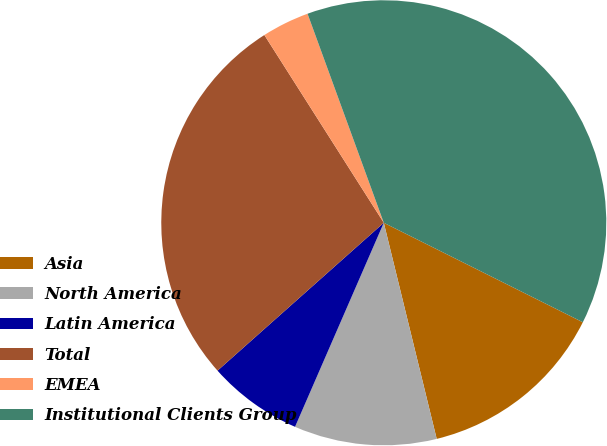Convert chart. <chart><loc_0><loc_0><loc_500><loc_500><pie_chart><fcel>Asia<fcel>North America<fcel>Latin America<fcel>Total<fcel>EMEA<fcel>Institutional Clients Group<nl><fcel>13.8%<fcel>10.35%<fcel>6.9%<fcel>27.55%<fcel>3.45%<fcel>37.94%<nl></chart> 